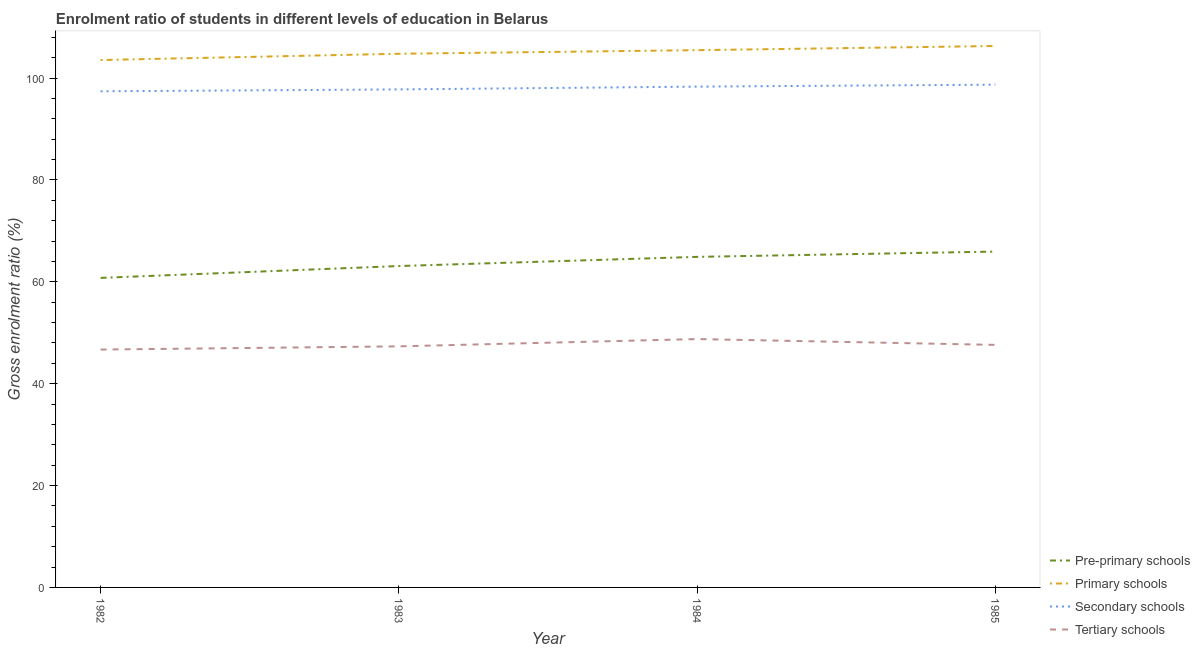What is the gross enrolment ratio in pre-primary schools in 1985?
Offer a very short reply. 65.93. Across all years, what is the maximum gross enrolment ratio in secondary schools?
Your answer should be very brief. 98.7. Across all years, what is the minimum gross enrolment ratio in tertiary schools?
Offer a terse response. 46.69. What is the total gross enrolment ratio in tertiary schools in the graph?
Offer a very short reply. 190.39. What is the difference between the gross enrolment ratio in pre-primary schools in 1983 and that in 1984?
Give a very brief answer. -1.8. What is the difference between the gross enrolment ratio in primary schools in 1984 and the gross enrolment ratio in tertiary schools in 1985?
Ensure brevity in your answer.  57.85. What is the average gross enrolment ratio in primary schools per year?
Your response must be concise. 105.01. In the year 1985, what is the difference between the gross enrolment ratio in pre-primary schools and gross enrolment ratio in secondary schools?
Your answer should be compact. -32.76. In how many years, is the gross enrolment ratio in tertiary schools greater than 4 %?
Provide a succinct answer. 4. What is the ratio of the gross enrolment ratio in pre-primary schools in 1983 to that in 1985?
Offer a terse response. 0.96. What is the difference between the highest and the second highest gross enrolment ratio in tertiary schools?
Offer a very short reply. 1.14. What is the difference between the highest and the lowest gross enrolment ratio in tertiary schools?
Ensure brevity in your answer.  2.06. In how many years, is the gross enrolment ratio in primary schools greater than the average gross enrolment ratio in primary schools taken over all years?
Make the answer very short. 2. Is it the case that in every year, the sum of the gross enrolment ratio in pre-primary schools and gross enrolment ratio in primary schools is greater than the gross enrolment ratio in secondary schools?
Give a very brief answer. Yes. Is the gross enrolment ratio in pre-primary schools strictly less than the gross enrolment ratio in tertiary schools over the years?
Make the answer very short. No. What is the difference between two consecutive major ticks on the Y-axis?
Your answer should be very brief. 20. Does the graph contain any zero values?
Keep it short and to the point. No. Where does the legend appear in the graph?
Your response must be concise. Bottom right. How many legend labels are there?
Make the answer very short. 4. What is the title of the graph?
Offer a terse response. Enrolment ratio of students in different levels of education in Belarus. What is the label or title of the Y-axis?
Make the answer very short. Gross enrolment ratio (%). What is the Gross enrolment ratio (%) in Pre-primary schools in 1982?
Your answer should be compact. 60.76. What is the Gross enrolment ratio (%) of Primary schools in 1982?
Your answer should be compact. 103.53. What is the Gross enrolment ratio (%) of Secondary schools in 1982?
Offer a very short reply. 97.39. What is the Gross enrolment ratio (%) of Tertiary schools in 1982?
Provide a succinct answer. 46.69. What is the Gross enrolment ratio (%) in Pre-primary schools in 1983?
Offer a terse response. 63.09. What is the Gross enrolment ratio (%) in Primary schools in 1983?
Offer a very short reply. 104.76. What is the Gross enrolment ratio (%) of Secondary schools in 1983?
Give a very brief answer. 97.76. What is the Gross enrolment ratio (%) of Tertiary schools in 1983?
Make the answer very short. 47.32. What is the Gross enrolment ratio (%) in Pre-primary schools in 1984?
Offer a very short reply. 64.89. What is the Gross enrolment ratio (%) in Primary schools in 1984?
Ensure brevity in your answer.  105.46. What is the Gross enrolment ratio (%) of Secondary schools in 1984?
Provide a succinct answer. 98.31. What is the Gross enrolment ratio (%) of Tertiary schools in 1984?
Offer a very short reply. 48.76. What is the Gross enrolment ratio (%) of Pre-primary schools in 1985?
Offer a terse response. 65.93. What is the Gross enrolment ratio (%) in Primary schools in 1985?
Ensure brevity in your answer.  106.28. What is the Gross enrolment ratio (%) of Secondary schools in 1985?
Your response must be concise. 98.7. What is the Gross enrolment ratio (%) of Tertiary schools in 1985?
Provide a short and direct response. 47.61. Across all years, what is the maximum Gross enrolment ratio (%) in Pre-primary schools?
Offer a very short reply. 65.93. Across all years, what is the maximum Gross enrolment ratio (%) in Primary schools?
Your answer should be compact. 106.28. Across all years, what is the maximum Gross enrolment ratio (%) in Secondary schools?
Your answer should be very brief. 98.7. Across all years, what is the maximum Gross enrolment ratio (%) in Tertiary schools?
Your response must be concise. 48.76. Across all years, what is the minimum Gross enrolment ratio (%) of Pre-primary schools?
Give a very brief answer. 60.76. Across all years, what is the minimum Gross enrolment ratio (%) of Primary schools?
Your answer should be very brief. 103.53. Across all years, what is the minimum Gross enrolment ratio (%) of Secondary schools?
Offer a very short reply. 97.39. Across all years, what is the minimum Gross enrolment ratio (%) in Tertiary schools?
Provide a succinct answer. 46.69. What is the total Gross enrolment ratio (%) of Pre-primary schools in the graph?
Provide a short and direct response. 254.67. What is the total Gross enrolment ratio (%) in Primary schools in the graph?
Provide a short and direct response. 420.04. What is the total Gross enrolment ratio (%) in Secondary schools in the graph?
Offer a terse response. 392.16. What is the total Gross enrolment ratio (%) of Tertiary schools in the graph?
Provide a succinct answer. 190.39. What is the difference between the Gross enrolment ratio (%) of Pre-primary schools in 1982 and that in 1983?
Make the answer very short. -2.33. What is the difference between the Gross enrolment ratio (%) of Primary schools in 1982 and that in 1983?
Offer a very short reply. -1.23. What is the difference between the Gross enrolment ratio (%) in Secondary schools in 1982 and that in 1983?
Provide a succinct answer. -0.37. What is the difference between the Gross enrolment ratio (%) of Tertiary schools in 1982 and that in 1983?
Provide a succinct answer. -0.63. What is the difference between the Gross enrolment ratio (%) in Pre-primary schools in 1982 and that in 1984?
Offer a very short reply. -4.13. What is the difference between the Gross enrolment ratio (%) of Primary schools in 1982 and that in 1984?
Your answer should be compact. -1.94. What is the difference between the Gross enrolment ratio (%) in Secondary schools in 1982 and that in 1984?
Keep it short and to the point. -0.92. What is the difference between the Gross enrolment ratio (%) in Tertiary schools in 1982 and that in 1984?
Your answer should be very brief. -2.06. What is the difference between the Gross enrolment ratio (%) of Pre-primary schools in 1982 and that in 1985?
Your answer should be compact. -5.17. What is the difference between the Gross enrolment ratio (%) of Primary schools in 1982 and that in 1985?
Ensure brevity in your answer.  -2.75. What is the difference between the Gross enrolment ratio (%) in Secondary schools in 1982 and that in 1985?
Make the answer very short. -1.3. What is the difference between the Gross enrolment ratio (%) of Tertiary schools in 1982 and that in 1985?
Keep it short and to the point. -0.92. What is the difference between the Gross enrolment ratio (%) of Pre-primary schools in 1983 and that in 1984?
Offer a very short reply. -1.8. What is the difference between the Gross enrolment ratio (%) of Primary schools in 1983 and that in 1984?
Make the answer very short. -0.71. What is the difference between the Gross enrolment ratio (%) in Secondary schools in 1983 and that in 1984?
Provide a short and direct response. -0.55. What is the difference between the Gross enrolment ratio (%) of Tertiary schools in 1983 and that in 1984?
Provide a short and direct response. -1.43. What is the difference between the Gross enrolment ratio (%) in Pre-primary schools in 1983 and that in 1985?
Your answer should be very brief. -2.84. What is the difference between the Gross enrolment ratio (%) of Primary schools in 1983 and that in 1985?
Make the answer very short. -1.52. What is the difference between the Gross enrolment ratio (%) of Secondary schools in 1983 and that in 1985?
Keep it short and to the point. -0.93. What is the difference between the Gross enrolment ratio (%) of Tertiary schools in 1983 and that in 1985?
Your answer should be compact. -0.29. What is the difference between the Gross enrolment ratio (%) of Pre-primary schools in 1984 and that in 1985?
Make the answer very short. -1.04. What is the difference between the Gross enrolment ratio (%) of Primary schools in 1984 and that in 1985?
Make the answer very short. -0.82. What is the difference between the Gross enrolment ratio (%) of Secondary schools in 1984 and that in 1985?
Provide a short and direct response. -0.39. What is the difference between the Gross enrolment ratio (%) in Tertiary schools in 1984 and that in 1985?
Your answer should be compact. 1.14. What is the difference between the Gross enrolment ratio (%) of Pre-primary schools in 1982 and the Gross enrolment ratio (%) of Primary schools in 1983?
Provide a succinct answer. -44. What is the difference between the Gross enrolment ratio (%) of Pre-primary schools in 1982 and the Gross enrolment ratio (%) of Secondary schools in 1983?
Your answer should be compact. -37. What is the difference between the Gross enrolment ratio (%) of Pre-primary schools in 1982 and the Gross enrolment ratio (%) of Tertiary schools in 1983?
Provide a succinct answer. 13.44. What is the difference between the Gross enrolment ratio (%) in Primary schools in 1982 and the Gross enrolment ratio (%) in Secondary schools in 1983?
Ensure brevity in your answer.  5.77. What is the difference between the Gross enrolment ratio (%) in Primary schools in 1982 and the Gross enrolment ratio (%) in Tertiary schools in 1983?
Offer a very short reply. 56.21. What is the difference between the Gross enrolment ratio (%) of Secondary schools in 1982 and the Gross enrolment ratio (%) of Tertiary schools in 1983?
Ensure brevity in your answer.  50.07. What is the difference between the Gross enrolment ratio (%) of Pre-primary schools in 1982 and the Gross enrolment ratio (%) of Primary schools in 1984?
Provide a short and direct response. -44.7. What is the difference between the Gross enrolment ratio (%) in Pre-primary schools in 1982 and the Gross enrolment ratio (%) in Secondary schools in 1984?
Offer a terse response. -37.55. What is the difference between the Gross enrolment ratio (%) of Pre-primary schools in 1982 and the Gross enrolment ratio (%) of Tertiary schools in 1984?
Your response must be concise. 12.01. What is the difference between the Gross enrolment ratio (%) in Primary schools in 1982 and the Gross enrolment ratio (%) in Secondary schools in 1984?
Your response must be concise. 5.22. What is the difference between the Gross enrolment ratio (%) of Primary schools in 1982 and the Gross enrolment ratio (%) of Tertiary schools in 1984?
Give a very brief answer. 54.77. What is the difference between the Gross enrolment ratio (%) in Secondary schools in 1982 and the Gross enrolment ratio (%) in Tertiary schools in 1984?
Ensure brevity in your answer.  48.64. What is the difference between the Gross enrolment ratio (%) in Pre-primary schools in 1982 and the Gross enrolment ratio (%) in Primary schools in 1985?
Make the answer very short. -45.52. What is the difference between the Gross enrolment ratio (%) of Pre-primary schools in 1982 and the Gross enrolment ratio (%) of Secondary schools in 1985?
Give a very brief answer. -37.93. What is the difference between the Gross enrolment ratio (%) in Pre-primary schools in 1982 and the Gross enrolment ratio (%) in Tertiary schools in 1985?
Provide a short and direct response. 13.15. What is the difference between the Gross enrolment ratio (%) in Primary schools in 1982 and the Gross enrolment ratio (%) in Secondary schools in 1985?
Give a very brief answer. 4.83. What is the difference between the Gross enrolment ratio (%) in Primary schools in 1982 and the Gross enrolment ratio (%) in Tertiary schools in 1985?
Your answer should be compact. 55.92. What is the difference between the Gross enrolment ratio (%) of Secondary schools in 1982 and the Gross enrolment ratio (%) of Tertiary schools in 1985?
Ensure brevity in your answer.  49.78. What is the difference between the Gross enrolment ratio (%) of Pre-primary schools in 1983 and the Gross enrolment ratio (%) of Primary schools in 1984?
Make the answer very short. -42.38. What is the difference between the Gross enrolment ratio (%) in Pre-primary schools in 1983 and the Gross enrolment ratio (%) in Secondary schools in 1984?
Keep it short and to the point. -35.22. What is the difference between the Gross enrolment ratio (%) in Pre-primary schools in 1983 and the Gross enrolment ratio (%) in Tertiary schools in 1984?
Make the answer very short. 14.33. What is the difference between the Gross enrolment ratio (%) in Primary schools in 1983 and the Gross enrolment ratio (%) in Secondary schools in 1984?
Offer a terse response. 6.45. What is the difference between the Gross enrolment ratio (%) of Primary schools in 1983 and the Gross enrolment ratio (%) of Tertiary schools in 1984?
Make the answer very short. 56. What is the difference between the Gross enrolment ratio (%) of Secondary schools in 1983 and the Gross enrolment ratio (%) of Tertiary schools in 1984?
Your response must be concise. 49.01. What is the difference between the Gross enrolment ratio (%) in Pre-primary schools in 1983 and the Gross enrolment ratio (%) in Primary schools in 1985?
Your answer should be compact. -43.19. What is the difference between the Gross enrolment ratio (%) in Pre-primary schools in 1983 and the Gross enrolment ratio (%) in Secondary schools in 1985?
Keep it short and to the point. -35.61. What is the difference between the Gross enrolment ratio (%) in Pre-primary schools in 1983 and the Gross enrolment ratio (%) in Tertiary schools in 1985?
Ensure brevity in your answer.  15.48. What is the difference between the Gross enrolment ratio (%) of Primary schools in 1983 and the Gross enrolment ratio (%) of Secondary schools in 1985?
Your answer should be compact. 6.06. What is the difference between the Gross enrolment ratio (%) of Primary schools in 1983 and the Gross enrolment ratio (%) of Tertiary schools in 1985?
Make the answer very short. 57.15. What is the difference between the Gross enrolment ratio (%) of Secondary schools in 1983 and the Gross enrolment ratio (%) of Tertiary schools in 1985?
Give a very brief answer. 50.15. What is the difference between the Gross enrolment ratio (%) in Pre-primary schools in 1984 and the Gross enrolment ratio (%) in Primary schools in 1985?
Provide a succinct answer. -41.39. What is the difference between the Gross enrolment ratio (%) in Pre-primary schools in 1984 and the Gross enrolment ratio (%) in Secondary schools in 1985?
Your answer should be very brief. -33.81. What is the difference between the Gross enrolment ratio (%) of Pre-primary schools in 1984 and the Gross enrolment ratio (%) of Tertiary schools in 1985?
Provide a short and direct response. 17.28. What is the difference between the Gross enrolment ratio (%) in Primary schools in 1984 and the Gross enrolment ratio (%) in Secondary schools in 1985?
Offer a terse response. 6.77. What is the difference between the Gross enrolment ratio (%) of Primary schools in 1984 and the Gross enrolment ratio (%) of Tertiary schools in 1985?
Offer a very short reply. 57.85. What is the difference between the Gross enrolment ratio (%) of Secondary schools in 1984 and the Gross enrolment ratio (%) of Tertiary schools in 1985?
Give a very brief answer. 50.7. What is the average Gross enrolment ratio (%) of Pre-primary schools per year?
Keep it short and to the point. 63.67. What is the average Gross enrolment ratio (%) in Primary schools per year?
Your answer should be very brief. 105.01. What is the average Gross enrolment ratio (%) of Secondary schools per year?
Make the answer very short. 98.04. What is the average Gross enrolment ratio (%) of Tertiary schools per year?
Offer a very short reply. 47.6. In the year 1982, what is the difference between the Gross enrolment ratio (%) in Pre-primary schools and Gross enrolment ratio (%) in Primary schools?
Provide a succinct answer. -42.77. In the year 1982, what is the difference between the Gross enrolment ratio (%) in Pre-primary schools and Gross enrolment ratio (%) in Secondary schools?
Ensure brevity in your answer.  -36.63. In the year 1982, what is the difference between the Gross enrolment ratio (%) of Pre-primary schools and Gross enrolment ratio (%) of Tertiary schools?
Your answer should be compact. 14.07. In the year 1982, what is the difference between the Gross enrolment ratio (%) of Primary schools and Gross enrolment ratio (%) of Secondary schools?
Your answer should be very brief. 6.14. In the year 1982, what is the difference between the Gross enrolment ratio (%) in Primary schools and Gross enrolment ratio (%) in Tertiary schools?
Provide a succinct answer. 56.84. In the year 1982, what is the difference between the Gross enrolment ratio (%) of Secondary schools and Gross enrolment ratio (%) of Tertiary schools?
Provide a succinct answer. 50.7. In the year 1983, what is the difference between the Gross enrolment ratio (%) of Pre-primary schools and Gross enrolment ratio (%) of Primary schools?
Your answer should be compact. -41.67. In the year 1983, what is the difference between the Gross enrolment ratio (%) in Pre-primary schools and Gross enrolment ratio (%) in Secondary schools?
Your answer should be compact. -34.67. In the year 1983, what is the difference between the Gross enrolment ratio (%) in Pre-primary schools and Gross enrolment ratio (%) in Tertiary schools?
Provide a succinct answer. 15.76. In the year 1983, what is the difference between the Gross enrolment ratio (%) in Primary schools and Gross enrolment ratio (%) in Secondary schools?
Make the answer very short. 7. In the year 1983, what is the difference between the Gross enrolment ratio (%) in Primary schools and Gross enrolment ratio (%) in Tertiary schools?
Your answer should be compact. 57.44. In the year 1983, what is the difference between the Gross enrolment ratio (%) in Secondary schools and Gross enrolment ratio (%) in Tertiary schools?
Provide a short and direct response. 50.44. In the year 1984, what is the difference between the Gross enrolment ratio (%) of Pre-primary schools and Gross enrolment ratio (%) of Primary schools?
Provide a short and direct response. -40.58. In the year 1984, what is the difference between the Gross enrolment ratio (%) in Pre-primary schools and Gross enrolment ratio (%) in Secondary schools?
Your response must be concise. -33.42. In the year 1984, what is the difference between the Gross enrolment ratio (%) of Pre-primary schools and Gross enrolment ratio (%) of Tertiary schools?
Your answer should be very brief. 16.13. In the year 1984, what is the difference between the Gross enrolment ratio (%) in Primary schools and Gross enrolment ratio (%) in Secondary schools?
Provide a short and direct response. 7.16. In the year 1984, what is the difference between the Gross enrolment ratio (%) of Primary schools and Gross enrolment ratio (%) of Tertiary schools?
Keep it short and to the point. 56.71. In the year 1984, what is the difference between the Gross enrolment ratio (%) of Secondary schools and Gross enrolment ratio (%) of Tertiary schools?
Provide a succinct answer. 49.55. In the year 1985, what is the difference between the Gross enrolment ratio (%) of Pre-primary schools and Gross enrolment ratio (%) of Primary schools?
Provide a short and direct response. -40.35. In the year 1985, what is the difference between the Gross enrolment ratio (%) of Pre-primary schools and Gross enrolment ratio (%) of Secondary schools?
Your response must be concise. -32.76. In the year 1985, what is the difference between the Gross enrolment ratio (%) of Pre-primary schools and Gross enrolment ratio (%) of Tertiary schools?
Make the answer very short. 18.32. In the year 1985, what is the difference between the Gross enrolment ratio (%) of Primary schools and Gross enrolment ratio (%) of Secondary schools?
Your answer should be very brief. 7.59. In the year 1985, what is the difference between the Gross enrolment ratio (%) in Primary schools and Gross enrolment ratio (%) in Tertiary schools?
Provide a succinct answer. 58.67. In the year 1985, what is the difference between the Gross enrolment ratio (%) of Secondary schools and Gross enrolment ratio (%) of Tertiary schools?
Give a very brief answer. 51.08. What is the ratio of the Gross enrolment ratio (%) of Pre-primary schools in 1982 to that in 1983?
Your answer should be compact. 0.96. What is the ratio of the Gross enrolment ratio (%) in Primary schools in 1982 to that in 1983?
Ensure brevity in your answer.  0.99. What is the ratio of the Gross enrolment ratio (%) of Tertiary schools in 1982 to that in 1983?
Your answer should be compact. 0.99. What is the ratio of the Gross enrolment ratio (%) in Pre-primary schools in 1982 to that in 1984?
Offer a very short reply. 0.94. What is the ratio of the Gross enrolment ratio (%) of Primary schools in 1982 to that in 1984?
Your answer should be very brief. 0.98. What is the ratio of the Gross enrolment ratio (%) in Tertiary schools in 1982 to that in 1984?
Your answer should be compact. 0.96. What is the ratio of the Gross enrolment ratio (%) in Pre-primary schools in 1982 to that in 1985?
Keep it short and to the point. 0.92. What is the ratio of the Gross enrolment ratio (%) in Primary schools in 1982 to that in 1985?
Keep it short and to the point. 0.97. What is the ratio of the Gross enrolment ratio (%) of Secondary schools in 1982 to that in 1985?
Provide a succinct answer. 0.99. What is the ratio of the Gross enrolment ratio (%) of Tertiary schools in 1982 to that in 1985?
Provide a succinct answer. 0.98. What is the ratio of the Gross enrolment ratio (%) of Pre-primary schools in 1983 to that in 1984?
Offer a very short reply. 0.97. What is the ratio of the Gross enrolment ratio (%) in Primary schools in 1983 to that in 1984?
Your answer should be very brief. 0.99. What is the ratio of the Gross enrolment ratio (%) in Secondary schools in 1983 to that in 1984?
Provide a short and direct response. 0.99. What is the ratio of the Gross enrolment ratio (%) in Tertiary schools in 1983 to that in 1984?
Your answer should be compact. 0.97. What is the ratio of the Gross enrolment ratio (%) in Pre-primary schools in 1983 to that in 1985?
Your answer should be very brief. 0.96. What is the ratio of the Gross enrolment ratio (%) in Primary schools in 1983 to that in 1985?
Your response must be concise. 0.99. What is the ratio of the Gross enrolment ratio (%) in Tertiary schools in 1983 to that in 1985?
Offer a very short reply. 0.99. What is the ratio of the Gross enrolment ratio (%) in Pre-primary schools in 1984 to that in 1985?
Ensure brevity in your answer.  0.98. What is the ratio of the Gross enrolment ratio (%) in Primary schools in 1984 to that in 1985?
Your response must be concise. 0.99. What is the difference between the highest and the second highest Gross enrolment ratio (%) in Pre-primary schools?
Provide a short and direct response. 1.04. What is the difference between the highest and the second highest Gross enrolment ratio (%) of Primary schools?
Ensure brevity in your answer.  0.82. What is the difference between the highest and the second highest Gross enrolment ratio (%) of Secondary schools?
Provide a short and direct response. 0.39. What is the difference between the highest and the second highest Gross enrolment ratio (%) of Tertiary schools?
Ensure brevity in your answer.  1.14. What is the difference between the highest and the lowest Gross enrolment ratio (%) in Pre-primary schools?
Offer a terse response. 5.17. What is the difference between the highest and the lowest Gross enrolment ratio (%) of Primary schools?
Ensure brevity in your answer.  2.75. What is the difference between the highest and the lowest Gross enrolment ratio (%) of Secondary schools?
Your answer should be compact. 1.3. What is the difference between the highest and the lowest Gross enrolment ratio (%) in Tertiary schools?
Offer a very short reply. 2.06. 